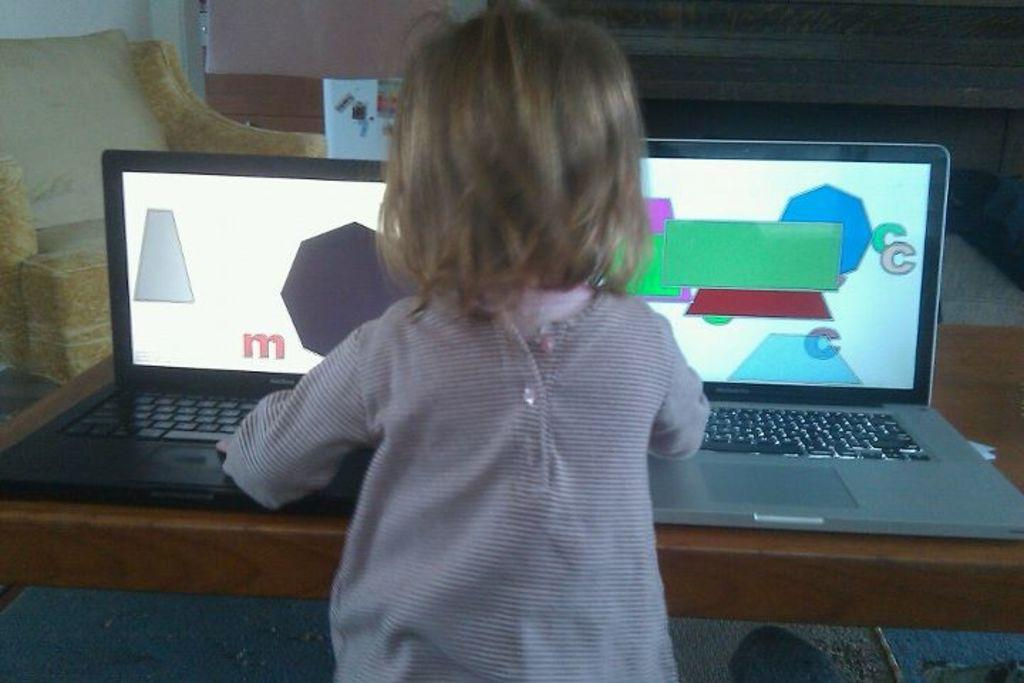What is the main subject of the image? There is a child in the image. What objects are on the table in the image? There are two laptops on a table. What can be seen on the laptop screens? The laptop screens are displaying colorful content. What type of furniture is present in the image? There is a couch in the image. What shape is the mist forming on the child's face in the image? There is no mist present in the image, so it is not possible to determine its shape. 